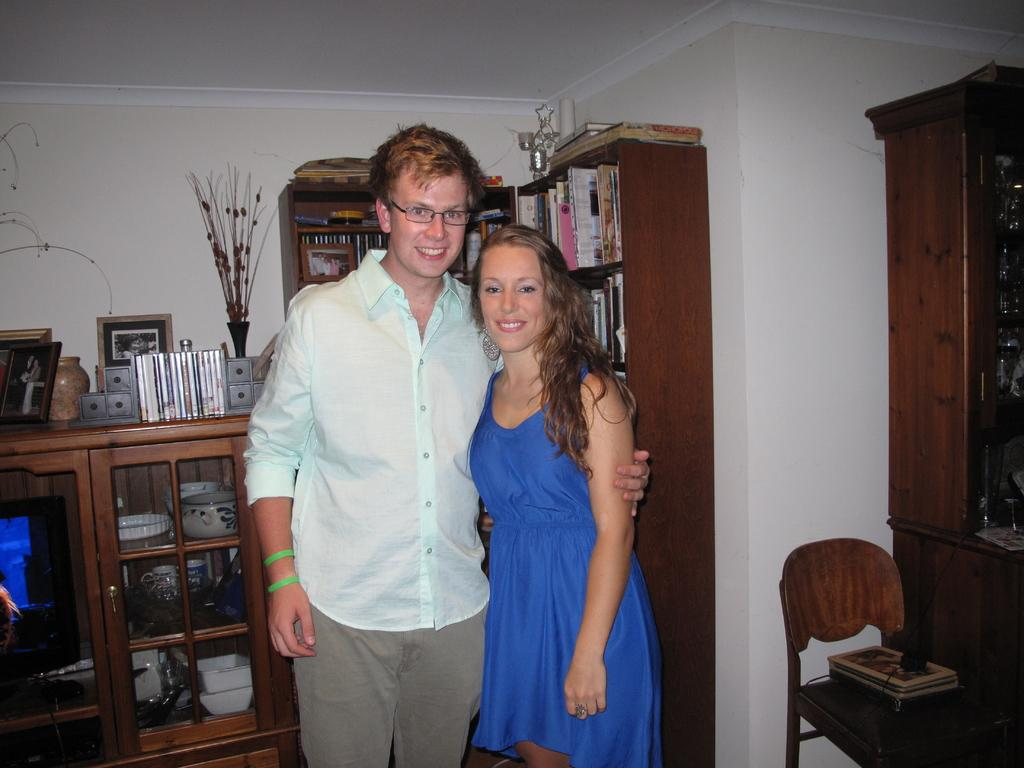How many people are in the living room in the image? There is a man and a woman in the living room in the image. What can be seen in the background of the living room? There are cupboards with bowls in the background, and there are books on the cupboards. What piece of furniture is on the right side of the image? There is a chair on the right side of the image. Where are the cattle located in the image? There are no cattle present in the image. How many libraries are visible in the image? There is no library visible in the image; it is a living room setting. 